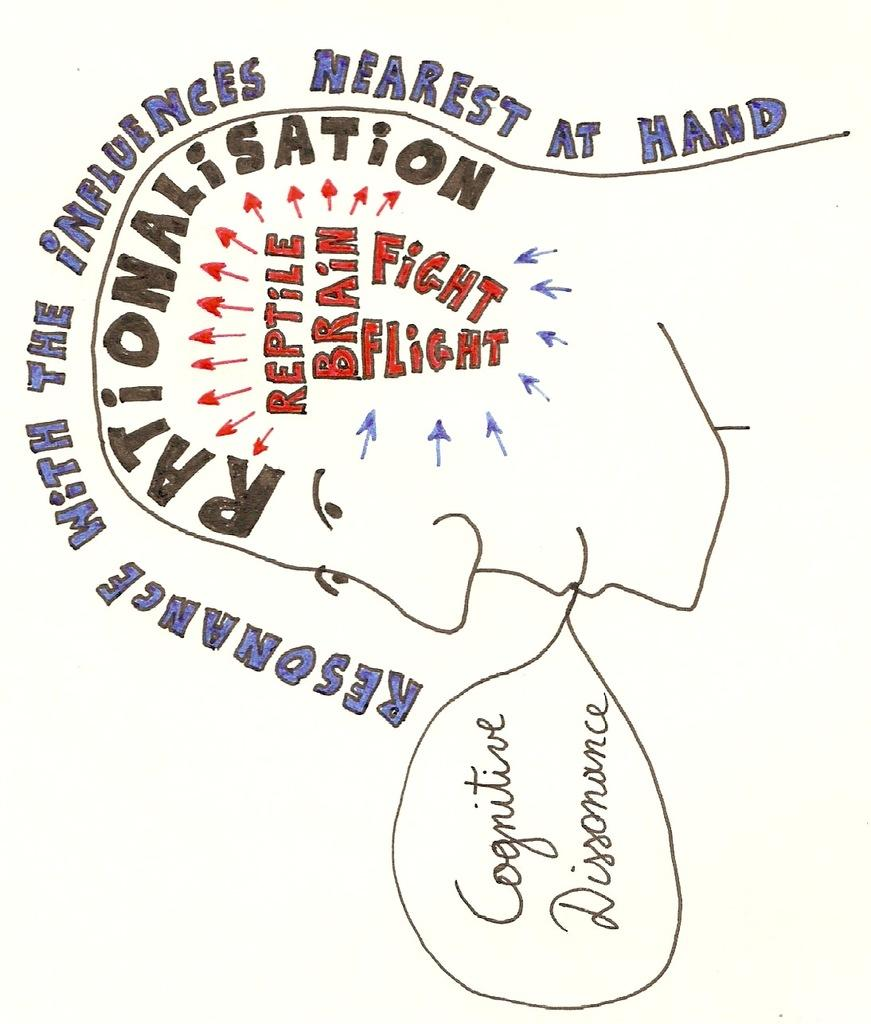What is depicted in the image? There is a face drawn in the image. What else can be seen in the image besides the face? There is text written in the image. How is the text in the image presented? The text is colored in the image. What type of milk is being used to develop the image? There is no milk or development process mentioned in the image or the provided facts. 